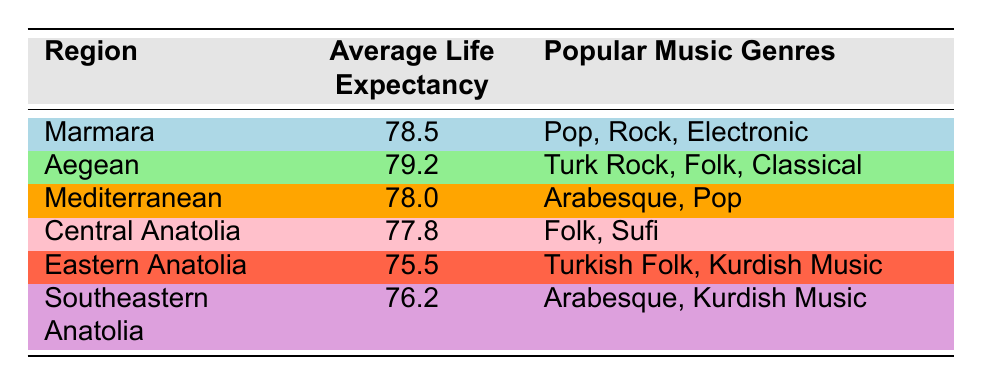What is the average life expectancy in the Aegean region? The average life expectancy for the Aegean region is explicitly listed in the table, which shows a value of 79.2 years.
Answer: 79.2 Which region has the lowest average life expectancy? By comparing the average life expectancy across all regions listed in the table, Eastern Anatolia has the lowest average at 75.5 years.
Answer: Eastern Anatolia What popular music genres are associated with the Southeastern Anatolia region? The table specifies that the popular music genres in the Southeastern Anatolia region are Arabesque and Kurdish Music.
Answer: Arabesque, Kurdish Music Is the average life expectancy higher in the Marmara region than in the Mediterranean region? The average life expectancy in the Marmara region is 78.5 years, while in the Mediterranean region it is 78.0 years. Since 78.5 is greater than 78.0, the answer is yes.
Answer: Yes What is the difference in average life expectancy between the Aegean and Eastern Anatolia regions? The average life expectancy in the Aegean region is 79.2 years and in Eastern Anatolia it is 75.5 years. The difference is 79.2 - 75.5 = 3.7 years.
Answer: 3.7 Which music genres might be popular in regions with lower life expectancy, such as Eastern Anatolia and Southeastern Anatolia? From the table, the popular music genres in Eastern Anatolia are Turkish Folk and Kurdish Music, while in Southeastern Anatolia, they are Arabesque and Kurdish Music. Thus, Kurdish Music appears as a common genre in both regions.
Answer: Kurdish Music Are there any regions where Arabesque music is popular, and what is their average life expectancy? According to the table, Arabesque music is popular in the Mediterranean and Southeastern Anatolia regions. Their average life expectancies are 78.0 years and 76.2 years, respectively.
Answer: Mediterranean: 78.0, Southeastern Anatolia: 76.2 Which region has the highest average life expectancy among the five regions listed? The Aegean region has the highest average life expectancy at 79.2 years, followed by Marmara. By looking at the values, we confirm this is the highest.
Answer: Aegean What can be inferred about the relationship between life expectancy and music genres in Turkey? The table shows a variety of music genres across different regions with varying life expectancies. Areas with higher life expectancy, like Aegean, tend to feature genres like Classical and Turk Rock, suggesting a possible connection between cultural expression and health. However, further analysis would be needed to confirm any causal relationships.
Answer: Higher life expectancy regions often feature diverse music genres 